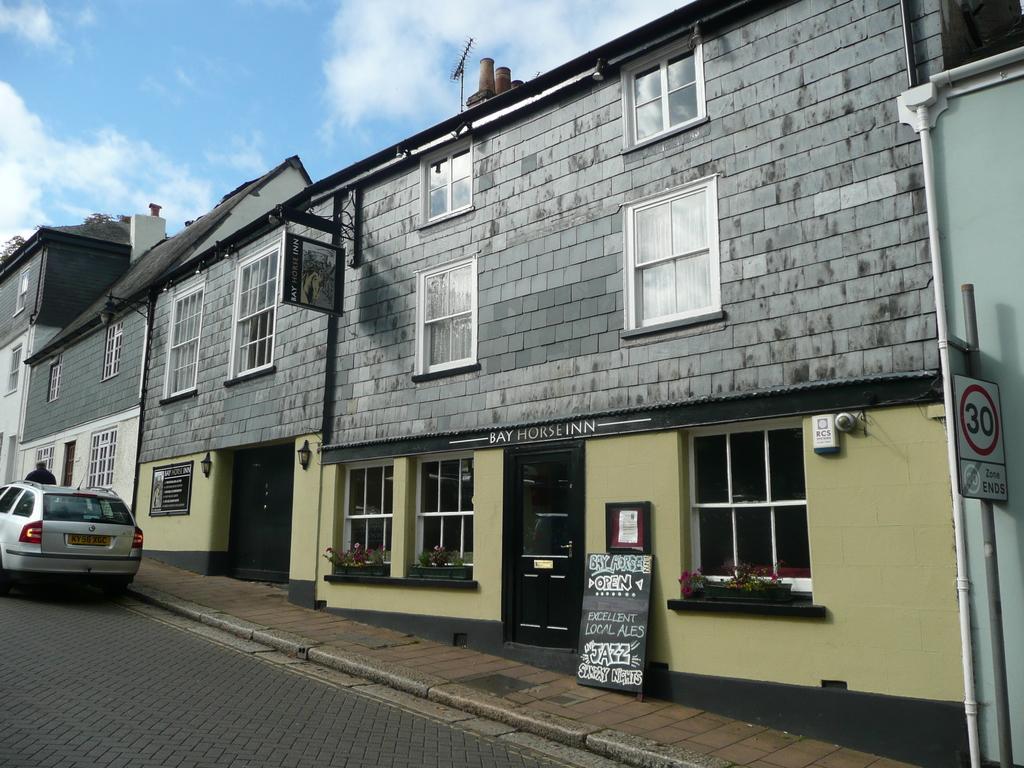Describe this image in one or two sentences. In this picture we can see a vehicle on the road, side we can see some buildings and we can see some boards. 